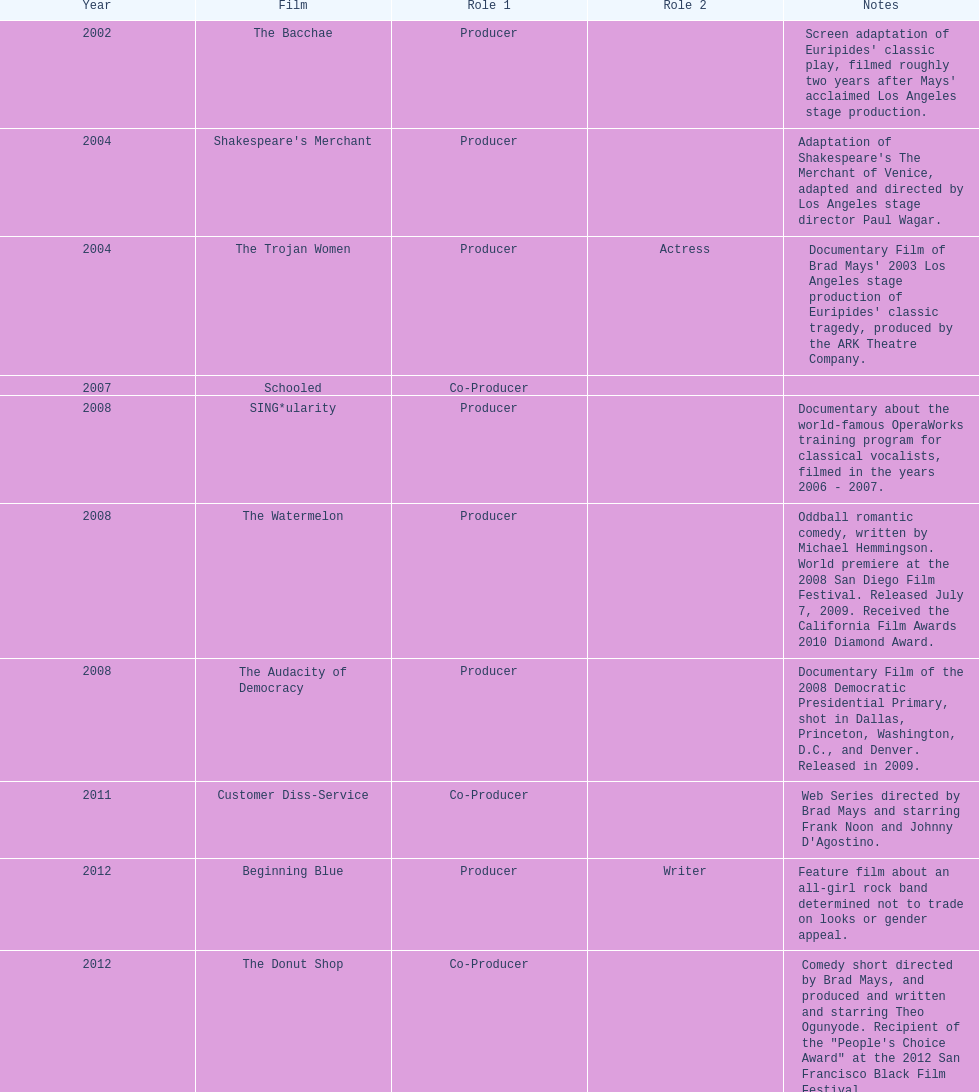Who was the first producer that made the film sing*ularity? Lorenda Starfelt. 